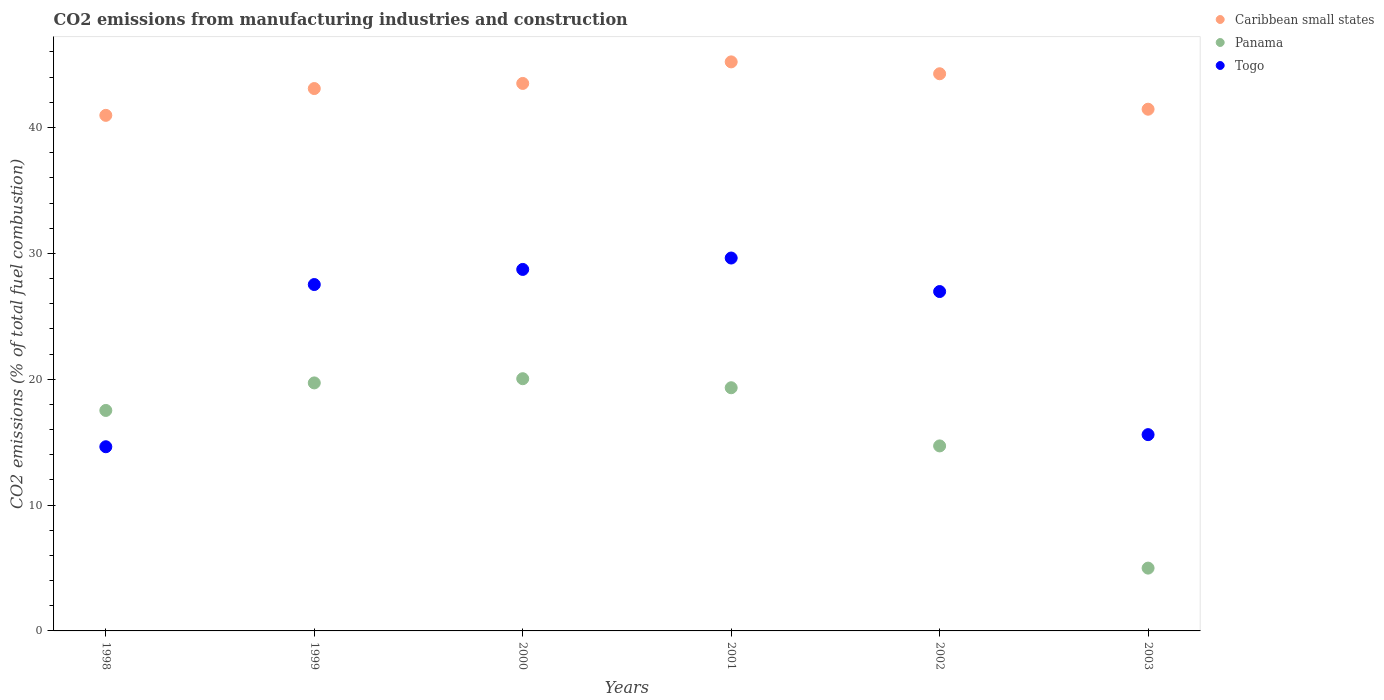What is the amount of CO2 emitted in Panama in 1998?
Offer a very short reply. 17.52. Across all years, what is the maximum amount of CO2 emitted in Caribbean small states?
Your answer should be compact. 45.21. Across all years, what is the minimum amount of CO2 emitted in Togo?
Your response must be concise. 14.63. In which year was the amount of CO2 emitted in Togo minimum?
Your answer should be very brief. 1998. What is the total amount of CO2 emitted in Caribbean small states in the graph?
Provide a short and direct response. 258.5. What is the difference between the amount of CO2 emitted in Panama in 2000 and that in 2003?
Offer a very short reply. 15.05. What is the difference between the amount of CO2 emitted in Caribbean small states in 1998 and the amount of CO2 emitted in Togo in 2003?
Make the answer very short. 25.37. What is the average amount of CO2 emitted in Togo per year?
Your answer should be very brief. 23.85. In the year 1999, what is the difference between the amount of CO2 emitted in Togo and amount of CO2 emitted in Panama?
Ensure brevity in your answer.  7.82. What is the ratio of the amount of CO2 emitted in Caribbean small states in 1998 to that in 2002?
Provide a short and direct response. 0.93. Is the amount of CO2 emitted in Togo in 1998 less than that in 2002?
Keep it short and to the point. Yes. Is the difference between the amount of CO2 emitted in Togo in 1999 and 2002 greater than the difference between the amount of CO2 emitted in Panama in 1999 and 2002?
Provide a succinct answer. No. What is the difference between the highest and the second highest amount of CO2 emitted in Caribbean small states?
Give a very brief answer. 0.94. What is the difference between the highest and the lowest amount of CO2 emitted in Caribbean small states?
Your answer should be compact. 4.25. In how many years, is the amount of CO2 emitted in Caribbean small states greater than the average amount of CO2 emitted in Caribbean small states taken over all years?
Give a very brief answer. 4. Is it the case that in every year, the sum of the amount of CO2 emitted in Togo and amount of CO2 emitted in Panama  is greater than the amount of CO2 emitted in Caribbean small states?
Your response must be concise. No. Is the amount of CO2 emitted in Togo strictly less than the amount of CO2 emitted in Caribbean small states over the years?
Provide a succinct answer. Yes. How many years are there in the graph?
Your answer should be very brief. 6. What is the difference between two consecutive major ticks on the Y-axis?
Your answer should be compact. 10. Does the graph contain any zero values?
Give a very brief answer. No. Does the graph contain grids?
Your answer should be very brief. No. How are the legend labels stacked?
Provide a succinct answer. Vertical. What is the title of the graph?
Offer a very short reply. CO2 emissions from manufacturing industries and construction. Does "Mexico" appear as one of the legend labels in the graph?
Your response must be concise. No. What is the label or title of the Y-axis?
Make the answer very short. CO2 emissions (% of total fuel combustion). What is the CO2 emissions (% of total fuel combustion) of Caribbean small states in 1998?
Your response must be concise. 40.97. What is the CO2 emissions (% of total fuel combustion) of Panama in 1998?
Offer a very short reply. 17.52. What is the CO2 emissions (% of total fuel combustion) of Togo in 1998?
Your answer should be compact. 14.63. What is the CO2 emissions (% of total fuel combustion) of Caribbean small states in 1999?
Ensure brevity in your answer.  43.1. What is the CO2 emissions (% of total fuel combustion) in Panama in 1999?
Keep it short and to the point. 19.71. What is the CO2 emissions (% of total fuel combustion) in Togo in 1999?
Ensure brevity in your answer.  27.52. What is the CO2 emissions (% of total fuel combustion) of Caribbean small states in 2000?
Give a very brief answer. 43.5. What is the CO2 emissions (% of total fuel combustion) of Panama in 2000?
Make the answer very short. 20.04. What is the CO2 emissions (% of total fuel combustion) in Togo in 2000?
Make the answer very short. 28.72. What is the CO2 emissions (% of total fuel combustion) in Caribbean small states in 2001?
Make the answer very short. 45.21. What is the CO2 emissions (% of total fuel combustion) in Panama in 2001?
Provide a short and direct response. 19.32. What is the CO2 emissions (% of total fuel combustion) in Togo in 2001?
Your answer should be very brief. 29.63. What is the CO2 emissions (% of total fuel combustion) in Caribbean small states in 2002?
Your answer should be compact. 44.27. What is the CO2 emissions (% of total fuel combustion) of Panama in 2002?
Provide a succinct answer. 14.7. What is the CO2 emissions (% of total fuel combustion) of Togo in 2002?
Provide a short and direct response. 26.97. What is the CO2 emissions (% of total fuel combustion) in Caribbean small states in 2003?
Give a very brief answer. 41.45. What is the CO2 emissions (% of total fuel combustion) in Panama in 2003?
Your answer should be very brief. 4.99. What is the CO2 emissions (% of total fuel combustion) of Togo in 2003?
Provide a succinct answer. 15.6. Across all years, what is the maximum CO2 emissions (% of total fuel combustion) in Caribbean small states?
Offer a terse response. 45.21. Across all years, what is the maximum CO2 emissions (% of total fuel combustion) in Panama?
Ensure brevity in your answer.  20.04. Across all years, what is the maximum CO2 emissions (% of total fuel combustion) in Togo?
Offer a very short reply. 29.63. Across all years, what is the minimum CO2 emissions (% of total fuel combustion) in Caribbean small states?
Provide a succinct answer. 40.97. Across all years, what is the minimum CO2 emissions (% of total fuel combustion) of Panama?
Your response must be concise. 4.99. Across all years, what is the minimum CO2 emissions (% of total fuel combustion) of Togo?
Your answer should be compact. 14.63. What is the total CO2 emissions (% of total fuel combustion) in Caribbean small states in the graph?
Your response must be concise. 258.5. What is the total CO2 emissions (% of total fuel combustion) of Panama in the graph?
Keep it short and to the point. 96.28. What is the total CO2 emissions (% of total fuel combustion) in Togo in the graph?
Offer a terse response. 143.07. What is the difference between the CO2 emissions (% of total fuel combustion) in Caribbean small states in 1998 and that in 1999?
Your answer should be compact. -2.13. What is the difference between the CO2 emissions (% of total fuel combustion) of Panama in 1998 and that in 1999?
Ensure brevity in your answer.  -2.19. What is the difference between the CO2 emissions (% of total fuel combustion) of Togo in 1998 and that in 1999?
Provide a short and direct response. -12.89. What is the difference between the CO2 emissions (% of total fuel combustion) in Caribbean small states in 1998 and that in 2000?
Provide a short and direct response. -2.54. What is the difference between the CO2 emissions (% of total fuel combustion) of Panama in 1998 and that in 2000?
Your answer should be very brief. -2.52. What is the difference between the CO2 emissions (% of total fuel combustion) of Togo in 1998 and that in 2000?
Your answer should be very brief. -14.09. What is the difference between the CO2 emissions (% of total fuel combustion) in Caribbean small states in 1998 and that in 2001?
Your response must be concise. -4.25. What is the difference between the CO2 emissions (% of total fuel combustion) of Panama in 1998 and that in 2001?
Offer a terse response. -1.8. What is the difference between the CO2 emissions (% of total fuel combustion) of Togo in 1998 and that in 2001?
Offer a very short reply. -15. What is the difference between the CO2 emissions (% of total fuel combustion) in Caribbean small states in 1998 and that in 2002?
Offer a terse response. -3.31. What is the difference between the CO2 emissions (% of total fuel combustion) in Panama in 1998 and that in 2002?
Your response must be concise. 2.82. What is the difference between the CO2 emissions (% of total fuel combustion) of Togo in 1998 and that in 2002?
Your response must be concise. -12.33. What is the difference between the CO2 emissions (% of total fuel combustion) of Caribbean small states in 1998 and that in 2003?
Offer a very short reply. -0.49. What is the difference between the CO2 emissions (% of total fuel combustion) in Panama in 1998 and that in 2003?
Give a very brief answer. 12.53. What is the difference between the CO2 emissions (% of total fuel combustion) in Togo in 1998 and that in 2003?
Offer a terse response. -0.96. What is the difference between the CO2 emissions (% of total fuel combustion) in Caribbean small states in 1999 and that in 2000?
Your answer should be compact. -0.41. What is the difference between the CO2 emissions (% of total fuel combustion) of Panama in 1999 and that in 2000?
Your answer should be compact. -0.33. What is the difference between the CO2 emissions (% of total fuel combustion) of Togo in 1999 and that in 2000?
Keep it short and to the point. -1.2. What is the difference between the CO2 emissions (% of total fuel combustion) in Caribbean small states in 1999 and that in 2001?
Give a very brief answer. -2.12. What is the difference between the CO2 emissions (% of total fuel combustion) of Panama in 1999 and that in 2001?
Your answer should be very brief. 0.38. What is the difference between the CO2 emissions (% of total fuel combustion) of Togo in 1999 and that in 2001?
Provide a succinct answer. -2.11. What is the difference between the CO2 emissions (% of total fuel combustion) in Caribbean small states in 1999 and that in 2002?
Your response must be concise. -1.18. What is the difference between the CO2 emissions (% of total fuel combustion) in Panama in 1999 and that in 2002?
Offer a terse response. 5.01. What is the difference between the CO2 emissions (% of total fuel combustion) in Togo in 1999 and that in 2002?
Offer a very short reply. 0.56. What is the difference between the CO2 emissions (% of total fuel combustion) of Caribbean small states in 1999 and that in 2003?
Your answer should be very brief. 1.64. What is the difference between the CO2 emissions (% of total fuel combustion) of Panama in 1999 and that in 2003?
Give a very brief answer. 14.72. What is the difference between the CO2 emissions (% of total fuel combustion) of Togo in 1999 and that in 2003?
Offer a very short reply. 11.93. What is the difference between the CO2 emissions (% of total fuel combustion) in Caribbean small states in 2000 and that in 2001?
Give a very brief answer. -1.71. What is the difference between the CO2 emissions (% of total fuel combustion) in Panama in 2000 and that in 2001?
Your answer should be compact. 0.72. What is the difference between the CO2 emissions (% of total fuel combustion) in Togo in 2000 and that in 2001?
Provide a succinct answer. -0.91. What is the difference between the CO2 emissions (% of total fuel combustion) in Caribbean small states in 2000 and that in 2002?
Give a very brief answer. -0.77. What is the difference between the CO2 emissions (% of total fuel combustion) of Panama in 2000 and that in 2002?
Ensure brevity in your answer.  5.34. What is the difference between the CO2 emissions (% of total fuel combustion) of Togo in 2000 and that in 2002?
Offer a very short reply. 1.76. What is the difference between the CO2 emissions (% of total fuel combustion) in Caribbean small states in 2000 and that in 2003?
Ensure brevity in your answer.  2.05. What is the difference between the CO2 emissions (% of total fuel combustion) in Panama in 2000 and that in 2003?
Provide a succinct answer. 15.05. What is the difference between the CO2 emissions (% of total fuel combustion) in Togo in 2000 and that in 2003?
Offer a very short reply. 13.13. What is the difference between the CO2 emissions (% of total fuel combustion) in Caribbean small states in 2001 and that in 2002?
Keep it short and to the point. 0.94. What is the difference between the CO2 emissions (% of total fuel combustion) in Panama in 2001 and that in 2002?
Give a very brief answer. 4.62. What is the difference between the CO2 emissions (% of total fuel combustion) in Togo in 2001 and that in 2002?
Offer a very short reply. 2.66. What is the difference between the CO2 emissions (% of total fuel combustion) in Caribbean small states in 2001 and that in 2003?
Ensure brevity in your answer.  3.76. What is the difference between the CO2 emissions (% of total fuel combustion) in Panama in 2001 and that in 2003?
Ensure brevity in your answer.  14.33. What is the difference between the CO2 emissions (% of total fuel combustion) of Togo in 2001 and that in 2003?
Provide a short and direct response. 14.03. What is the difference between the CO2 emissions (% of total fuel combustion) of Caribbean small states in 2002 and that in 2003?
Your answer should be very brief. 2.82. What is the difference between the CO2 emissions (% of total fuel combustion) of Panama in 2002 and that in 2003?
Your response must be concise. 9.71. What is the difference between the CO2 emissions (% of total fuel combustion) of Togo in 2002 and that in 2003?
Keep it short and to the point. 11.37. What is the difference between the CO2 emissions (% of total fuel combustion) of Caribbean small states in 1998 and the CO2 emissions (% of total fuel combustion) of Panama in 1999?
Make the answer very short. 21.26. What is the difference between the CO2 emissions (% of total fuel combustion) of Caribbean small states in 1998 and the CO2 emissions (% of total fuel combustion) of Togo in 1999?
Provide a short and direct response. 13.44. What is the difference between the CO2 emissions (% of total fuel combustion) of Panama in 1998 and the CO2 emissions (% of total fuel combustion) of Togo in 1999?
Ensure brevity in your answer.  -10. What is the difference between the CO2 emissions (% of total fuel combustion) of Caribbean small states in 1998 and the CO2 emissions (% of total fuel combustion) of Panama in 2000?
Provide a succinct answer. 20.92. What is the difference between the CO2 emissions (% of total fuel combustion) in Caribbean small states in 1998 and the CO2 emissions (% of total fuel combustion) in Togo in 2000?
Offer a very short reply. 12.24. What is the difference between the CO2 emissions (% of total fuel combustion) of Panama in 1998 and the CO2 emissions (% of total fuel combustion) of Togo in 2000?
Your response must be concise. -11.21. What is the difference between the CO2 emissions (% of total fuel combustion) in Caribbean small states in 1998 and the CO2 emissions (% of total fuel combustion) in Panama in 2001?
Provide a short and direct response. 21.64. What is the difference between the CO2 emissions (% of total fuel combustion) in Caribbean small states in 1998 and the CO2 emissions (% of total fuel combustion) in Togo in 2001?
Provide a succinct answer. 11.34. What is the difference between the CO2 emissions (% of total fuel combustion) in Panama in 1998 and the CO2 emissions (% of total fuel combustion) in Togo in 2001?
Your answer should be compact. -12.11. What is the difference between the CO2 emissions (% of total fuel combustion) of Caribbean small states in 1998 and the CO2 emissions (% of total fuel combustion) of Panama in 2002?
Keep it short and to the point. 26.27. What is the difference between the CO2 emissions (% of total fuel combustion) in Caribbean small states in 1998 and the CO2 emissions (% of total fuel combustion) in Togo in 2002?
Provide a succinct answer. 14. What is the difference between the CO2 emissions (% of total fuel combustion) in Panama in 1998 and the CO2 emissions (% of total fuel combustion) in Togo in 2002?
Your response must be concise. -9.45. What is the difference between the CO2 emissions (% of total fuel combustion) in Caribbean small states in 1998 and the CO2 emissions (% of total fuel combustion) in Panama in 2003?
Your answer should be very brief. 35.97. What is the difference between the CO2 emissions (% of total fuel combustion) in Caribbean small states in 1998 and the CO2 emissions (% of total fuel combustion) in Togo in 2003?
Give a very brief answer. 25.37. What is the difference between the CO2 emissions (% of total fuel combustion) in Panama in 1998 and the CO2 emissions (% of total fuel combustion) in Togo in 2003?
Provide a succinct answer. 1.92. What is the difference between the CO2 emissions (% of total fuel combustion) in Caribbean small states in 1999 and the CO2 emissions (% of total fuel combustion) in Panama in 2000?
Give a very brief answer. 23.05. What is the difference between the CO2 emissions (% of total fuel combustion) in Caribbean small states in 1999 and the CO2 emissions (% of total fuel combustion) in Togo in 2000?
Keep it short and to the point. 14.37. What is the difference between the CO2 emissions (% of total fuel combustion) of Panama in 1999 and the CO2 emissions (% of total fuel combustion) of Togo in 2000?
Offer a very short reply. -9.02. What is the difference between the CO2 emissions (% of total fuel combustion) in Caribbean small states in 1999 and the CO2 emissions (% of total fuel combustion) in Panama in 2001?
Your response must be concise. 23.77. What is the difference between the CO2 emissions (% of total fuel combustion) in Caribbean small states in 1999 and the CO2 emissions (% of total fuel combustion) in Togo in 2001?
Give a very brief answer. 13.47. What is the difference between the CO2 emissions (% of total fuel combustion) in Panama in 1999 and the CO2 emissions (% of total fuel combustion) in Togo in 2001?
Your answer should be very brief. -9.92. What is the difference between the CO2 emissions (% of total fuel combustion) in Caribbean small states in 1999 and the CO2 emissions (% of total fuel combustion) in Panama in 2002?
Ensure brevity in your answer.  28.39. What is the difference between the CO2 emissions (% of total fuel combustion) in Caribbean small states in 1999 and the CO2 emissions (% of total fuel combustion) in Togo in 2002?
Offer a very short reply. 16.13. What is the difference between the CO2 emissions (% of total fuel combustion) in Panama in 1999 and the CO2 emissions (% of total fuel combustion) in Togo in 2002?
Make the answer very short. -7.26. What is the difference between the CO2 emissions (% of total fuel combustion) in Caribbean small states in 1999 and the CO2 emissions (% of total fuel combustion) in Panama in 2003?
Your response must be concise. 38.1. What is the difference between the CO2 emissions (% of total fuel combustion) of Caribbean small states in 1999 and the CO2 emissions (% of total fuel combustion) of Togo in 2003?
Make the answer very short. 27.5. What is the difference between the CO2 emissions (% of total fuel combustion) in Panama in 1999 and the CO2 emissions (% of total fuel combustion) in Togo in 2003?
Give a very brief answer. 4.11. What is the difference between the CO2 emissions (% of total fuel combustion) of Caribbean small states in 2000 and the CO2 emissions (% of total fuel combustion) of Panama in 2001?
Offer a very short reply. 24.18. What is the difference between the CO2 emissions (% of total fuel combustion) in Caribbean small states in 2000 and the CO2 emissions (% of total fuel combustion) in Togo in 2001?
Provide a short and direct response. 13.87. What is the difference between the CO2 emissions (% of total fuel combustion) in Panama in 2000 and the CO2 emissions (% of total fuel combustion) in Togo in 2001?
Offer a very short reply. -9.59. What is the difference between the CO2 emissions (% of total fuel combustion) of Caribbean small states in 2000 and the CO2 emissions (% of total fuel combustion) of Panama in 2002?
Provide a succinct answer. 28.8. What is the difference between the CO2 emissions (% of total fuel combustion) of Caribbean small states in 2000 and the CO2 emissions (% of total fuel combustion) of Togo in 2002?
Provide a short and direct response. 16.54. What is the difference between the CO2 emissions (% of total fuel combustion) of Panama in 2000 and the CO2 emissions (% of total fuel combustion) of Togo in 2002?
Your answer should be compact. -6.93. What is the difference between the CO2 emissions (% of total fuel combustion) in Caribbean small states in 2000 and the CO2 emissions (% of total fuel combustion) in Panama in 2003?
Give a very brief answer. 38.51. What is the difference between the CO2 emissions (% of total fuel combustion) of Caribbean small states in 2000 and the CO2 emissions (% of total fuel combustion) of Togo in 2003?
Ensure brevity in your answer.  27.91. What is the difference between the CO2 emissions (% of total fuel combustion) in Panama in 2000 and the CO2 emissions (% of total fuel combustion) in Togo in 2003?
Provide a succinct answer. 4.44. What is the difference between the CO2 emissions (% of total fuel combustion) in Caribbean small states in 2001 and the CO2 emissions (% of total fuel combustion) in Panama in 2002?
Your answer should be compact. 30.51. What is the difference between the CO2 emissions (% of total fuel combustion) in Caribbean small states in 2001 and the CO2 emissions (% of total fuel combustion) in Togo in 2002?
Provide a short and direct response. 18.25. What is the difference between the CO2 emissions (% of total fuel combustion) in Panama in 2001 and the CO2 emissions (% of total fuel combustion) in Togo in 2002?
Provide a succinct answer. -7.64. What is the difference between the CO2 emissions (% of total fuel combustion) of Caribbean small states in 2001 and the CO2 emissions (% of total fuel combustion) of Panama in 2003?
Provide a succinct answer. 40.22. What is the difference between the CO2 emissions (% of total fuel combustion) of Caribbean small states in 2001 and the CO2 emissions (% of total fuel combustion) of Togo in 2003?
Your answer should be compact. 29.62. What is the difference between the CO2 emissions (% of total fuel combustion) of Panama in 2001 and the CO2 emissions (% of total fuel combustion) of Togo in 2003?
Ensure brevity in your answer.  3.73. What is the difference between the CO2 emissions (% of total fuel combustion) of Caribbean small states in 2002 and the CO2 emissions (% of total fuel combustion) of Panama in 2003?
Provide a succinct answer. 39.28. What is the difference between the CO2 emissions (% of total fuel combustion) in Caribbean small states in 2002 and the CO2 emissions (% of total fuel combustion) in Togo in 2003?
Provide a succinct answer. 28.67. What is the difference between the CO2 emissions (% of total fuel combustion) in Panama in 2002 and the CO2 emissions (% of total fuel combustion) in Togo in 2003?
Offer a terse response. -0.9. What is the average CO2 emissions (% of total fuel combustion) of Caribbean small states per year?
Provide a succinct answer. 43.08. What is the average CO2 emissions (% of total fuel combustion) of Panama per year?
Offer a very short reply. 16.05. What is the average CO2 emissions (% of total fuel combustion) in Togo per year?
Provide a succinct answer. 23.85. In the year 1998, what is the difference between the CO2 emissions (% of total fuel combustion) of Caribbean small states and CO2 emissions (% of total fuel combustion) of Panama?
Your answer should be compact. 23.45. In the year 1998, what is the difference between the CO2 emissions (% of total fuel combustion) in Caribbean small states and CO2 emissions (% of total fuel combustion) in Togo?
Your answer should be compact. 26.33. In the year 1998, what is the difference between the CO2 emissions (% of total fuel combustion) in Panama and CO2 emissions (% of total fuel combustion) in Togo?
Your answer should be very brief. 2.88. In the year 1999, what is the difference between the CO2 emissions (% of total fuel combustion) in Caribbean small states and CO2 emissions (% of total fuel combustion) in Panama?
Provide a succinct answer. 23.39. In the year 1999, what is the difference between the CO2 emissions (% of total fuel combustion) in Caribbean small states and CO2 emissions (% of total fuel combustion) in Togo?
Provide a short and direct response. 15.57. In the year 1999, what is the difference between the CO2 emissions (% of total fuel combustion) in Panama and CO2 emissions (% of total fuel combustion) in Togo?
Offer a terse response. -7.82. In the year 2000, what is the difference between the CO2 emissions (% of total fuel combustion) in Caribbean small states and CO2 emissions (% of total fuel combustion) in Panama?
Make the answer very short. 23.46. In the year 2000, what is the difference between the CO2 emissions (% of total fuel combustion) of Caribbean small states and CO2 emissions (% of total fuel combustion) of Togo?
Offer a terse response. 14.78. In the year 2000, what is the difference between the CO2 emissions (% of total fuel combustion) of Panama and CO2 emissions (% of total fuel combustion) of Togo?
Your answer should be compact. -8.68. In the year 2001, what is the difference between the CO2 emissions (% of total fuel combustion) of Caribbean small states and CO2 emissions (% of total fuel combustion) of Panama?
Give a very brief answer. 25.89. In the year 2001, what is the difference between the CO2 emissions (% of total fuel combustion) in Caribbean small states and CO2 emissions (% of total fuel combustion) in Togo?
Provide a succinct answer. 15.58. In the year 2001, what is the difference between the CO2 emissions (% of total fuel combustion) of Panama and CO2 emissions (% of total fuel combustion) of Togo?
Offer a terse response. -10.31. In the year 2002, what is the difference between the CO2 emissions (% of total fuel combustion) of Caribbean small states and CO2 emissions (% of total fuel combustion) of Panama?
Your answer should be compact. 29.57. In the year 2002, what is the difference between the CO2 emissions (% of total fuel combustion) of Caribbean small states and CO2 emissions (% of total fuel combustion) of Togo?
Offer a terse response. 17.3. In the year 2002, what is the difference between the CO2 emissions (% of total fuel combustion) in Panama and CO2 emissions (% of total fuel combustion) in Togo?
Keep it short and to the point. -12.27. In the year 2003, what is the difference between the CO2 emissions (% of total fuel combustion) of Caribbean small states and CO2 emissions (% of total fuel combustion) of Panama?
Your response must be concise. 36.46. In the year 2003, what is the difference between the CO2 emissions (% of total fuel combustion) in Caribbean small states and CO2 emissions (% of total fuel combustion) in Togo?
Provide a short and direct response. 25.86. In the year 2003, what is the difference between the CO2 emissions (% of total fuel combustion) in Panama and CO2 emissions (% of total fuel combustion) in Togo?
Provide a succinct answer. -10.61. What is the ratio of the CO2 emissions (% of total fuel combustion) of Caribbean small states in 1998 to that in 1999?
Your answer should be very brief. 0.95. What is the ratio of the CO2 emissions (% of total fuel combustion) in Panama in 1998 to that in 1999?
Your response must be concise. 0.89. What is the ratio of the CO2 emissions (% of total fuel combustion) of Togo in 1998 to that in 1999?
Offer a very short reply. 0.53. What is the ratio of the CO2 emissions (% of total fuel combustion) in Caribbean small states in 1998 to that in 2000?
Ensure brevity in your answer.  0.94. What is the ratio of the CO2 emissions (% of total fuel combustion) of Panama in 1998 to that in 2000?
Your answer should be very brief. 0.87. What is the ratio of the CO2 emissions (% of total fuel combustion) in Togo in 1998 to that in 2000?
Your answer should be very brief. 0.51. What is the ratio of the CO2 emissions (% of total fuel combustion) of Caribbean small states in 1998 to that in 2001?
Your answer should be very brief. 0.91. What is the ratio of the CO2 emissions (% of total fuel combustion) of Panama in 1998 to that in 2001?
Provide a succinct answer. 0.91. What is the ratio of the CO2 emissions (% of total fuel combustion) in Togo in 1998 to that in 2001?
Offer a terse response. 0.49. What is the ratio of the CO2 emissions (% of total fuel combustion) of Caribbean small states in 1998 to that in 2002?
Offer a terse response. 0.93. What is the ratio of the CO2 emissions (% of total fuel combustion) of Panama in 1998 to that in 2002?
Keep it short and to the point. 1.19. What is the ratio of the CO2 emissions (% of total fuel combustion) of Togo in 1998 to that in 2002?
Provide a short and direct response. 0.54. What is the ratio of the CO2 emissions (% of total fuel combustion) in Panama in 1998 to that in 2003?
Make the answer very short. 3.51. What is the ratio of the CO2 emissions (% of total fuel combustion) of Togo in 1998 to that in 2003?
Your response must be concise. 0.94. What is the ratio of the CO2 emissions (% of total fuel combustion) in Panama in 1999 to that in 2000?
Provide a short and direct response. 0.98. What is the ratio of the CO2 emissions (% of total fuel combustion) in Togo in 1999 to that in 2000?
Make the answer very short. 0.96. What is the ratio of the CO2 emissions (% of total fuel combustion) in Caribbean small states in 1999 to that in 2001?
Keep it short and to the point. 0.95. What is the ratio of the CO2 emissions (% of total fuel combustion) of Panama in 1999 to that in 2001?
Keep it short and to the point. 1.02. What is the ratio of the CO2 emissions (% of total fuel combustion) of Togo in 1999 to that in 2001?
Your answer should be very brief. 0.93. What is the ratio of the CO2 emissions (% of total fuel combustion) in Caribbean small states in 1999 to that in 2002?
Your response must be concise. 0.97. What is the ratio of the CO2 emissions (% of total fuel combustion) of Panama in 1999 to that in 2002?
Ensure brevity in your answer.  1.34. What is the ratio of the CO2 emissions (% of total fuel combustion) of Togo in 1999 to that in 2002?
Your response must be concise. 1.02. What is the ratio of the CO2 emissions (% of total fuel combustion) of Caribbean small states in 1999 to that in 2003?
Your answer should be very brief. 1.04. What is the ratio of the CO2 emissions (% of total fuel combustion) in Panama in 1999 to that in 2003?
Ensure brevity in your answer.  3.95. What is the ratio of the CO2 emissions (% of total fuel combustion) of Togo in 1999 to that in 2003?
Offer a terse response. 1.76. What is the ratio of the CO2 emissions (% of total fuel combustion) of Caribbean small states in 2000 to that in 2001?
Provide a succinct answer. 0.96. What is the ratio of the CO2 emissions (% of total fuel combustion) in Panama in 2000 to that in 2001?
Provide a succinct answer. 1.04. What is the ratio of the CO2 emissions (% of total fuel combustion) in Togo in 2000 to that in 2001?
Your answer should be compact. 0.97. What is the ratio of the CO2 emissions (% of total fuel combustion) in Caribbean small states in 2000 to that in 2002?
Offer a very short reply. 0.98. What is the ratio of the CO2 emissions (% of total fuel combustion) of Panama in 2000 to that in 2002?
Your answer should be very brief. 1.36. What is the ratio of the CO2 emissions (% of total fuel combustion) of Togo in 2000 to that in 2002?
Your answer should be compact. 1.07. What is the ratio of the CO2 emissions (% of total fuel combustion) of Caribbean small states in 2000 to that in 2003?
Provide a short and direct response. 1.05. What is the ratio of the CO2 emissions (% of total fuel combustion) in Panama in 2000 to that in 2003?
Keep it short and to the point. 4.02. What is the ratio of the CO2 emissions (% of total fuel combustion) in Togo in 2000 to that in 2003?
Provide a succinct answer. 1.84. What is the ratio of the CO2 emissions (% of total fuel combustion) in Caribbean small states in 2001 to that in 2002?
Your response must be concise. 1.02. What is the ratio of the CO2 emissions (% of total fuel combustion) in Panama in 2001 to that in 2002?
Give a very brief answer. 1.31. What is the ratio of the CO2 emissions (% of total fuel combustion) in Togo in 2001 to that in 2002?
Your response must be concise. 1.1. What is the ratio of the CO2 emissions (% of total fuel combustion) in Caribbean small states in 2001 to that in 2003?
Provide a short and direct response. 1.09. What is the ratio of the CO2 emissions (% of total fuel combustion) of Panama in 2001 to that in 2003?
Your answer should be compact. 3.87. What is the ratio of the CO2 emissions (% of total fuel combustion) in Togo in 2001 to that in 2003?
Offer a terse response. 1.9. What is the ratio of the CO2 emissions (% of total fuel combustion) in Caribbean small states in 2002 to that in 2003?
Provide a succinct answer. 1.07. What is the ratio of the CO2 emissions (% of total fuel combustion) of Panama in 2002 to that in 2003?
Keep it short and to the point. 2.95. What is the ratio of the CO2 emissions (% of total fuel combustion) in Togo in 2002 to that in 2003?
Your response must be concise. 1.73. What is the difference between the highest and the second highest CO2 emissions (% of total fuel combustion) of Caribbean small states?
Keep it short and to the point. 0.94. What is the difference between the highest and the second highest CO2 emissions (% of total fuel combustion) of Panama?
Keep it short and to the point. 0.33. What is the difference between the highest and the second highest CO2 emissions (% of total fuel combustion) of Togo?
Your answer should be very brief. 0.91. What is the difference between the highest and the lowest CO2 emissions (% of total fuel combustion) of Caribbean small states?
Provide a short and direct response. 4.25. What is the difference between the highest and the lowest CO2 emissions (% of total fuel combustion) in Panama?
Offer a terse response. 15.05. What is the difference between the highest and the lowest CO2 emissions (% of total fuel combustion) of Togo?
Ensure brevity in your answer.  15. 